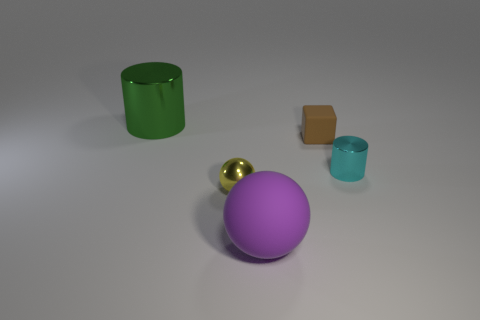Is there a big green object that is in front of the small thing on the left side of the purple ball?
Your answer should be compact. No. There is a object that is behind the cube; what is it made of?
Your answer should be very brief. Metal. Is the shape of the small matte thing the same as the large metallic object?
Give a very brief answer. No. The tiny thing in front of the small metal thing behind the tiny object in front of the cyan cylinder is what color?
Your answer should be very brief. Yellow. How many other small cyan things are the same shape as the cyan object?
Provide a short and direct response. 0. What is the size of the cylinder behind the metallic cylinder right of the tiny sphere?
Offer a terse response. Large. Do the cyan cylinder and the purple matte object have the same size?
Your response must be concise. No. Are there any metal cylinders in front of the shiny object that is to the left of the tiny metallic sphere in front of the small cyan shiny cylinder?
Make the answer very short. Yes. The purple sphere is what size?
Provide a succinct answer. Large. How many brown cubes have the same size as the yellow metallic sphere?
Provide a succinct answer. 1. 